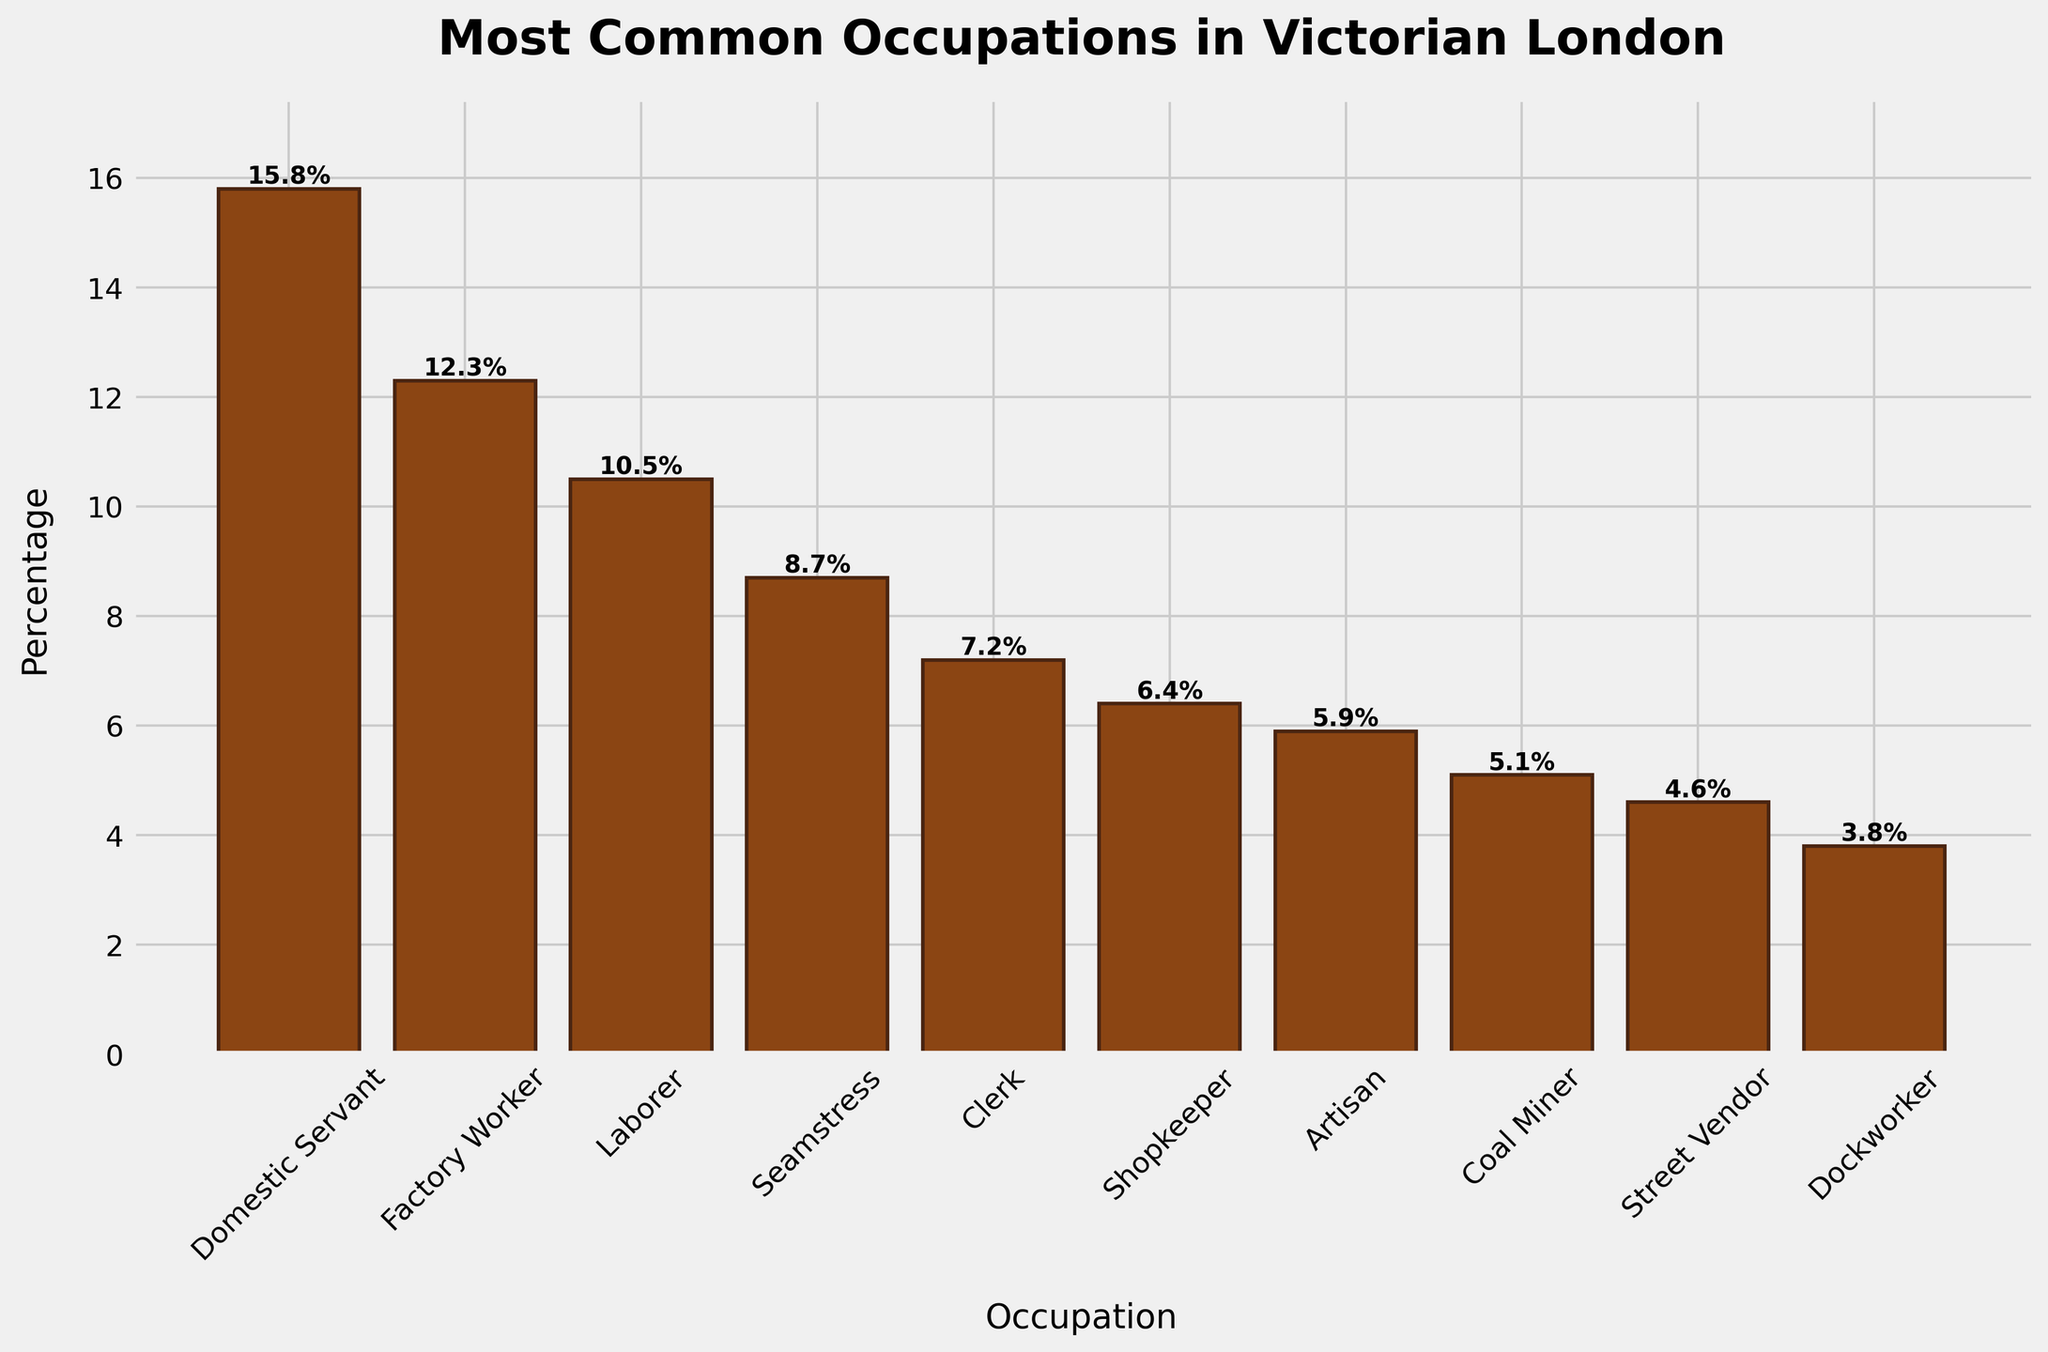Which occupation had the highest percentage in Victorian London? The Domestic Servant occupation had the highest percentage which can be clearly seen by the tallest bar in the chart, indicating 15.8%.
Answer: Domestic Servant Which occupations have a percentage greater than 10%? By inspecting the bars that exceed the 10% mark on the y-axis, we identify Domestic Servant, Factory Worker, and Laborer as the occupations greater than 10%.
Answer: Domestic Servant, Factory Worker, Laborer What is the total percentage of the top three most common occupations? The top three occupations are Domestic Servant (15.8%), Factory Worker (12.3%), and Laborer (10.5%). Summing these percentages: 15.8 + 12.3 + 10.5 = 38.6%.
Answer: 38.6% What is the difference in percentage between the most common and the least common occupation? The most common occupation is Domestic Servant at 15.8%, and the least common is Dockworker at 3.8%. The difference is calculated as 15.8 - 3.8 = 12.0%.
Answer: 12.0% Which is more common, a Seamstress or a Shopkeeper, and by how much? Seamstress has a percentage of 8.7%, and Shopkeeper has 6.4%. Seamstress is more common by 8.7 - 6.4 = 2.3%.
Answer: Seamstress by 2.3% How many occupations have a percentage between 5% and 10%? The occupations in this range are Seamstress (8.7%), Clerk (7.2%), Shopkeeper (6.4%), and Artisan (5.9%)—totaling four occupations.
Answer: 4 What is the average percentage of the bottom five occupations? The bottom five occupations are Shopkeeper (6.4%), Artisan (5.9%), Coal Miner (5.1%), Street Vendor (4.6%), and Dockworker (3.8%). Their sum is 6.4 + 5.9 + 5.1 + 4.6 + 3.8 = 25.8. The average is 25.8 / 5 = 5.16.
Answer: 5.16 Identify the occupation represented by the bar colored brown. All bars representing occupations like Domestic Servant, Factory Worker, Laborer, etc. are colored brown, meaning this color is used uniformly for all bars.
Answer: All occupations 